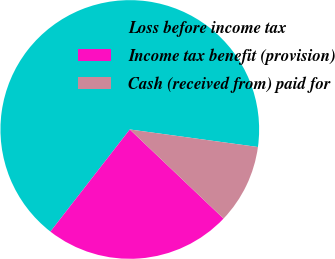Convert chart. <chart><loc_0><loc_0><loc_500><loc_500><pie_chart><fcel>Loss before income tax<fcel>Income tax benefit (provision)<fcel>Cash (received from) paid for<nl><fcel>66.65%<fcel>23.42%<fcel>9.93%<nl></chart> 